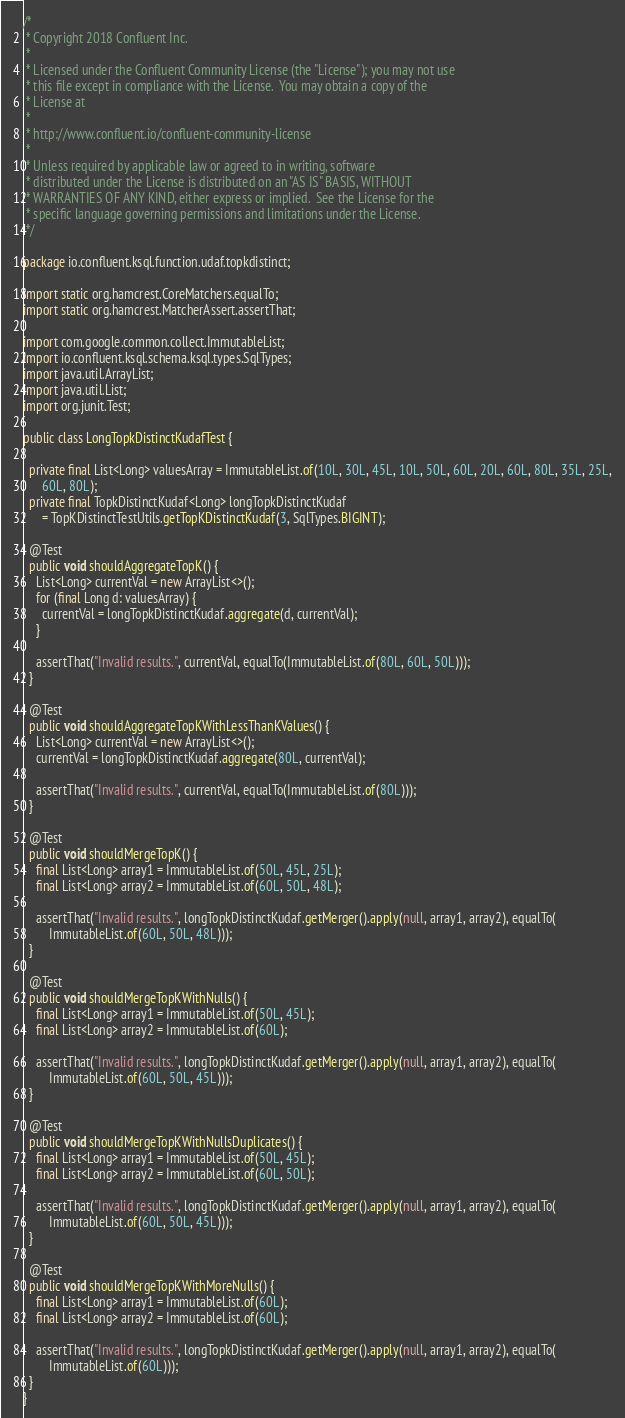<code> <loc_0><loc_0><loc_500><loc_500><_Java_>/*
 * Copyright 2018 Confluent Inc.
 *
 * Licensed under the Confluent Community License (the "License"); you may not use
 * this file except in compliance with the License.  You may obtain a copy of the
 * License at
 *
 * http://www.confluent.io/confluent-community-license
 *
 * Unless required by applicable law or agreed to in writing, software
 * distributed under the License is distributed on an "AS IS" BASIS, WITHOUT
 * WARRANTIES OF ANY KIND, either express or implied.  See the License for the
 * specific language governing permissions and limitations under the License.
 */

package io.confluent.ksql.function.udaf.topkdistinct;

import static org.hamcrest.CoreMatchers.equalTo;
import static org.hamcrest.MatcherAssert.assertThat;

import com.google.common.collect.ImmutableList;
import io.confluent.ksql.schema.ksql.types.SqlTypes;
import java.util.ArrayList;
import java.util.List;
import org.junit.Test;

public class LongTopkDistinctKudafTest {

  private final List<Long> valuesArray = ImmutableList.of(10L, 30L, 45L, 10L, 50L, 60L, 20L, 60L, 80L, 35L, 25L,
      60L, 80L);
  private final TopkDistinctKudaf<Long> longTopkDistinctKudaf
      = TopKDistinctTestUtils.getTopKDistinctKudaf(3, SqlTypes.BIGINT);

  @Test
  public void shouldAggregateTopK() {
    List<Long> currentVal = new ArrayList<>();
    for (final Long d: valuesArray) {
      currentVal = longTopkDistinctKudaf.aggregate(d, currentVal);
    }

    assertThat("Invalid results.", currentVal, equalTo(ImmutableList.of(80L, 60L, 50L)));
  }

  @Test
  public void shouldAggregateTopKWithLessThanKValues() {
    List<Long> currentVal = new ArrayList<>();
    currentVal = longTopkDistinctKudaf.aggregate(80L, currentVal);

    assertThat("Invalid results.", currentVal, equalTo(ImmutableList.of(80L)));
  }

  @Test
  public void shouldMergeTopK() {
    final List<Long> array1 = ImmutableList.of(50L, 45L, 25L);
    final List<Long> array2 = ImmutableList.of(60L, 50L, 48L);

    assertThat("Invalid results.", longTopkDistinctKudaf.getMerger().apply(null, array1, array2), equalTo(
        ImmutableList.of(60L, 50L, 48L)));
  }

  @Test
  public void shouldMergeTopKWithNulls() {
    final List<Long> array1 = ImmutableList.of(50L, 45L);
    final List<Long> array2 = ImmutableList.of(60L);

    assertThat("Invalid results.", longTopkDistinctKudaf.getMerger().apply(null, array1, array2), equalTo(
        ImmutableList.of(60L, 50L, 45L)));
  }

  @Test
  public void shouldMergeTopKWithNullsDuplicates() {
    final List<Long> array1 = ImmutableList.of(50L, 45L);
    final List<Long> array2 = ImmutableList.of(60L, 50L);

    assertThat("Invalid results.", longTopkDistinctKudaf.getMerger().apply(null, array1, array2), equalTo(
        ImmutableList.of(60L, 50L, 45L)));
  }

  @Test
  public void shouldMergeTopKWithMoreNulls() {
    final List<Long> array1 = ImmutableList.of(60L);
    final List<Long> array2 = ImmutableList.of(60L);

    assertThat("Invalid results.", longTopkDistinctKudaf.getMerger().apply(null, array1, array2), equalTo(
        ImmutableList.of(60L)));
  }
}</code> 